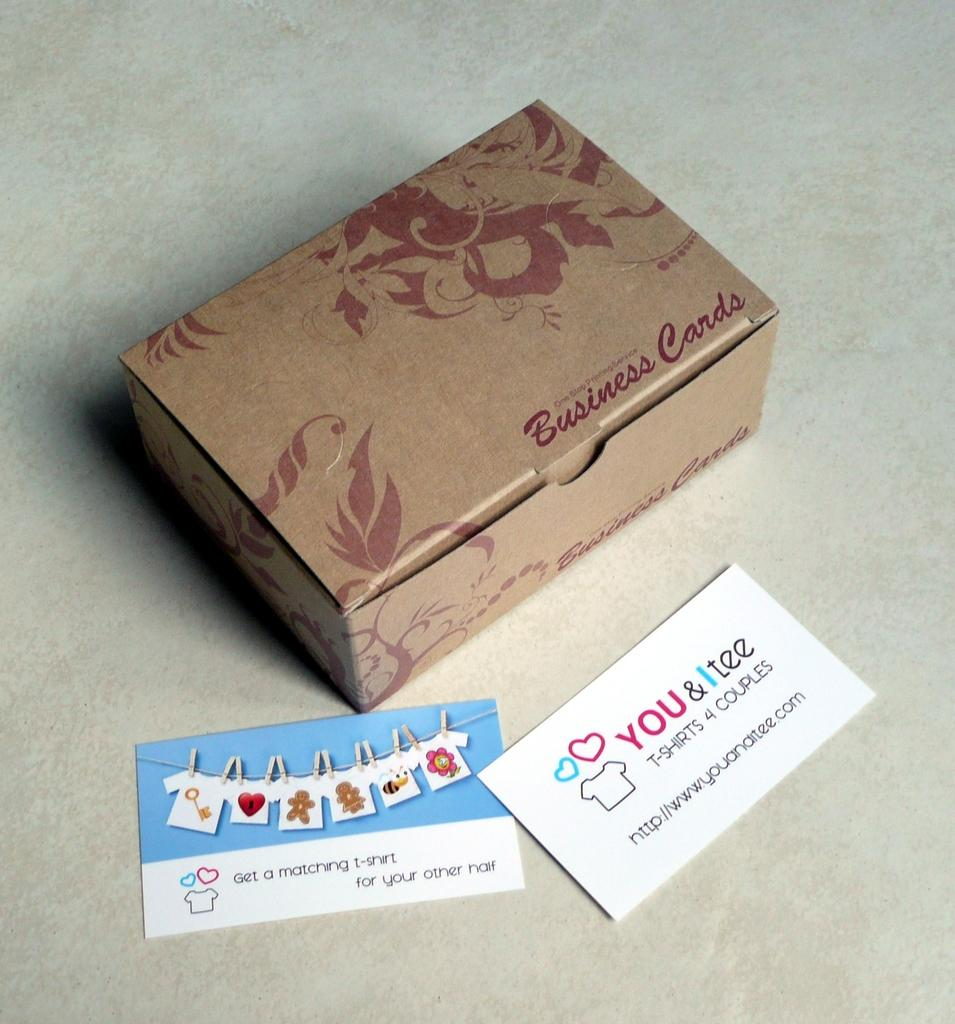What is the main object in the image? There is a box in the image. What else can be seen in the image besides the box? There are cards in the image. Where are the box and cards located? The box and cards are on a platform. What type of marble is used to decorate the platform in the image? There is no marble present in the image; the platform's material is not specified. What type of secretary is working behind the platform in the image? There is no secretary present in the image; the focus is on the box and cards on the platform. 